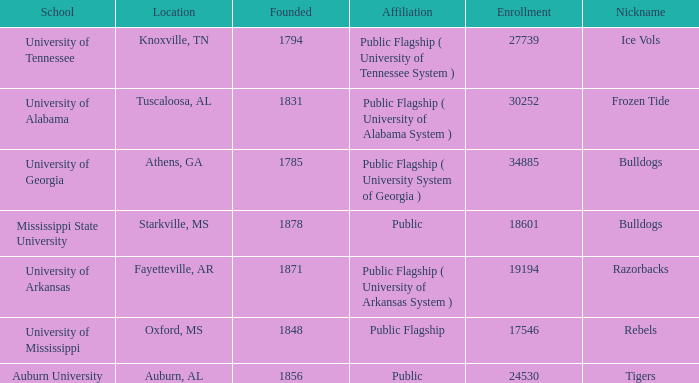Write the full table. {'header': ['School', 'Location', 'Founded', 'Affiliation', 'Enrollment', 'Nickname'], 'rows': [['University of Tennessee', 'Knoxville, TN', '1794', 'Public Flagship ( University of Tennessee System )', '27739', 'Ice Vols'], ['University of Alabama', 'Tuscaloosa, AL', '1831', 'Public Flagship ( University of Alabama System )', '30252', 'Frozen Tide'], ['University of Georgia', 'Athens, GA', '1785', 'Public Flagship ( University System of Georgia )', '34885', 'Bulldogs'], ['Mississippi State University', 'Starkville, MS', '1878', 'Public', '18601', 'Bulldogs'], ['University of Arkansas', 'Fayetteville, AR', '1871', 'Public Flagship ( University of Arkansas System )', '19194', 'Razorbacks'], ['University of Mississippi', 'Oxford, MS', '1848', 'Public Flagship', '17546', 'Rebels'], ['Auburn University', 'Auburn, AL', '1856', 'Public', '24530', 'Tigers']]} What is the nickname of the University of Alabama? Frozen Tide. 